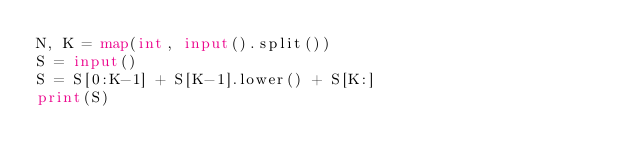Convert code to text. <code><loc_0><loc_0><loc_500><loc_500><_Python_>N, K = map(int, input().split())
S = input()
S = S[0:K-1] + S[K-1].lower() + S[K:]
print(S)</code> 